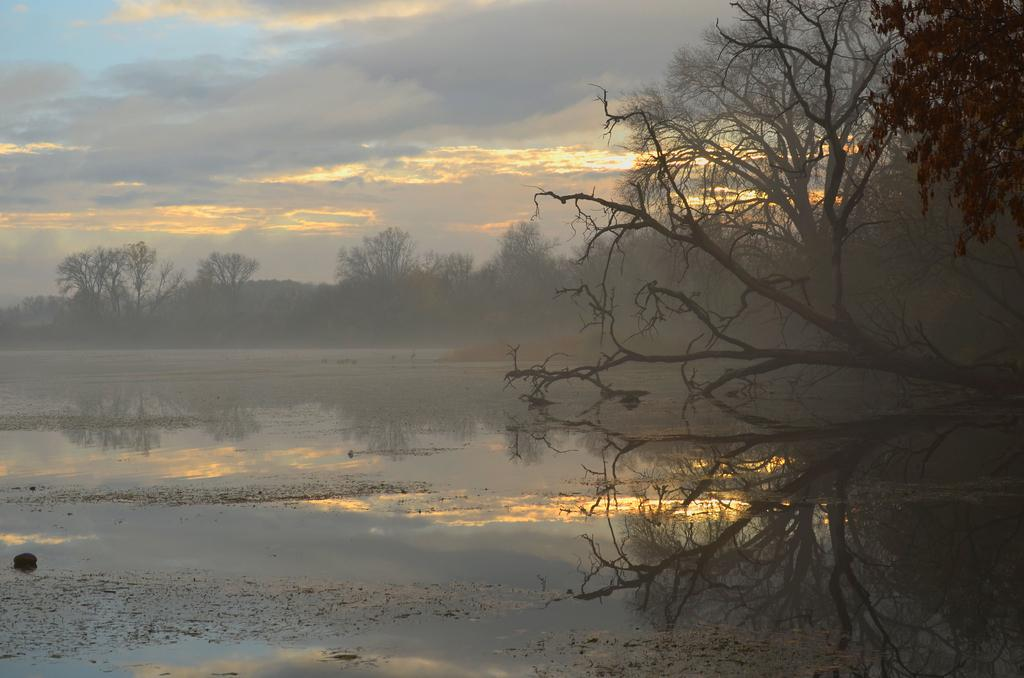What is visible in the image? Water is visible in the image. What can be seen in the background of the image? There are trees and clouds in the sky in the background of the image. What type of straw is being used to stir the water in the image? There is no straw present in the image, and the water is not being stirred. 